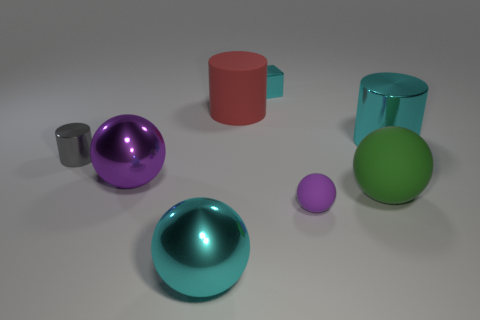What material is the large cylinder that is the same color as the small block?
Give a very brief answer. Metal. How many large rubber cylinders are the same color as the small cylinder?
Offer a very short reply. 0. The purple metallic sphere is what size?
Ensure brevity in your answer.  Large. There is a big green thing; is its shape the same as the metallic object that is to the left of the big purple ball?
Make the answer very short. No. The large cylinder that is made of the same material as the small cyan thing is what color?
Provide a succinct answer. Cyan. What is the size of the purple ball that is to the left of the red matte thing?
Your answer should be very brief. Large. Is the number of small cyan blocks that are in front of the tiny purple object less than the number of green objects?
Keep it short and to the point. Yes. Does the large matte cylinder have the same color as the small matte thing?
Provide a short and direct response. No. Is there anything else that is the same shape as the red rubber thing?
Offer a terse response. Yes. Are there fewer red matte objects than tiny shiny balls?
Offer a very short reply. No. 